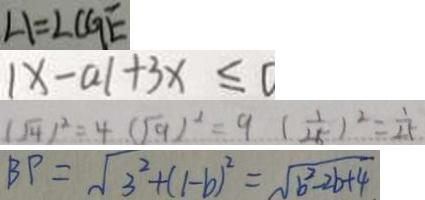<formula> <loc_0><loc_0><loc_500><loc_500>\angle 1 = \angle C G E 
 \vert x - a \vert + 3 x \leq 0 
 ( \sqrt { 4 } ) ^ { 2 } = 4 ( \sqrt { 9 } ) ^ { 2 } = 9 ( \frac { 1 } { 2 5 } ) ^ { 2 } = \frac { 1 } { 2 5 } 
 B P = \sqrt { 3 ^ { 2 } + ( 1 - b ) ^ { 2 } } = \sqrt { b ^ { 2 } - 2 b + 4 }</formula> 